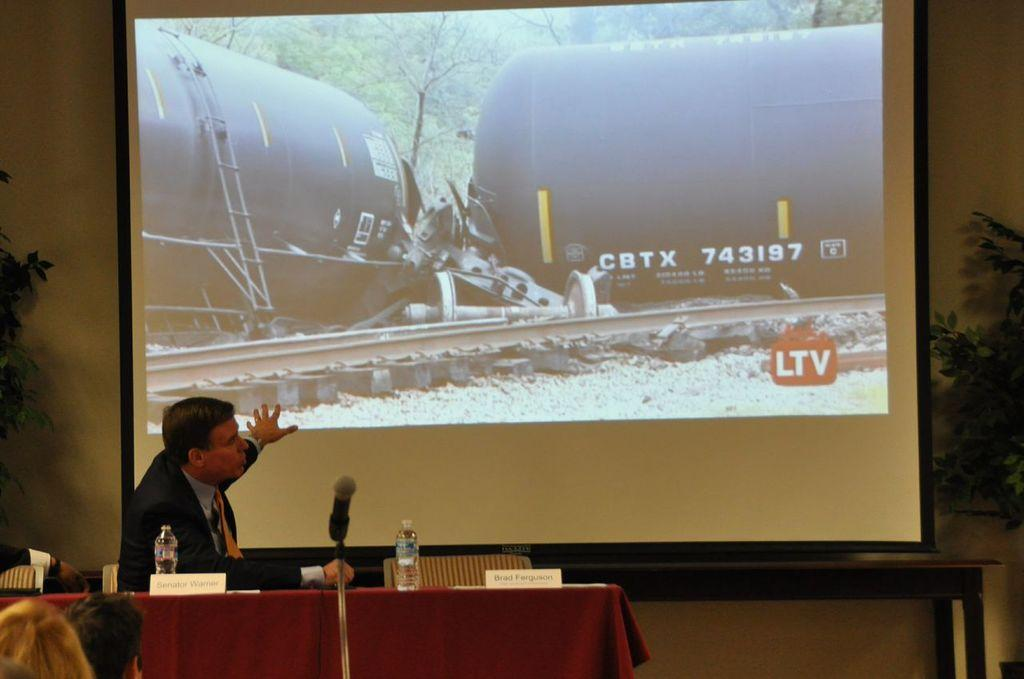<image>
Render a clear and concise summary of the photo. A slide of a train wreck that has tanker numbers CBTX 743197. 